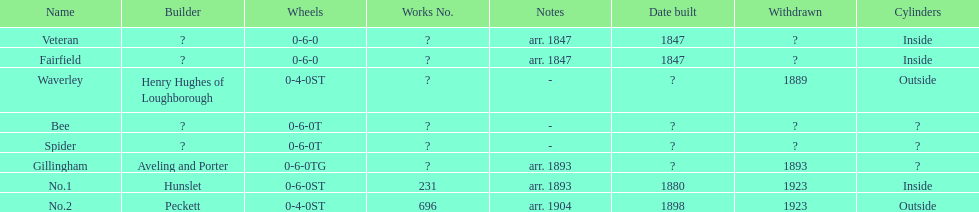Was no.1 or veteran built in 1847? Veteran. 